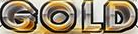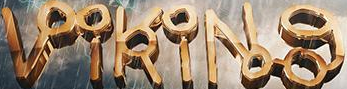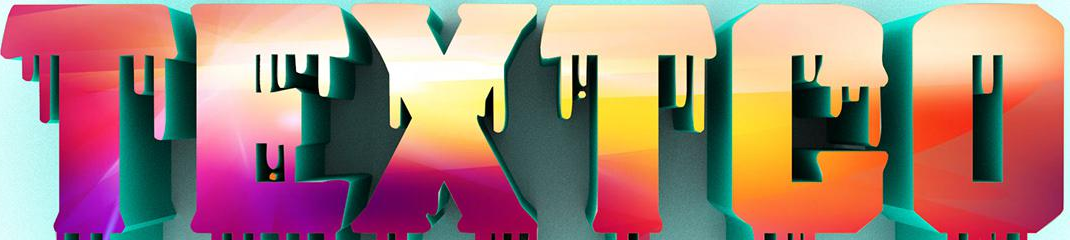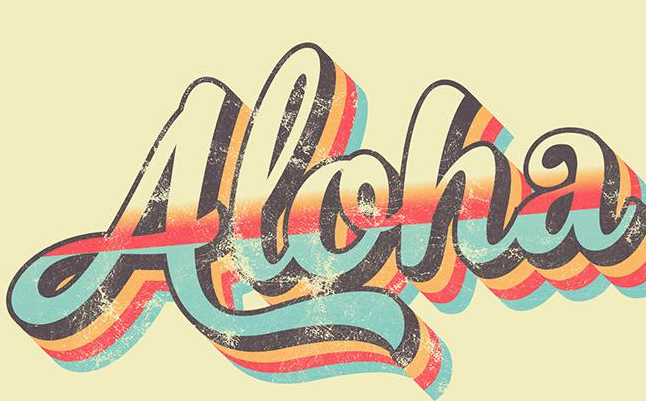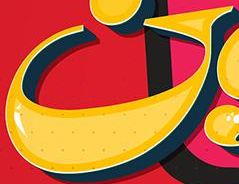Transcribe the words shown in these images in order, separated by a semicolon. GOLD; VikiNg; TEXTCO; Aloha; G 